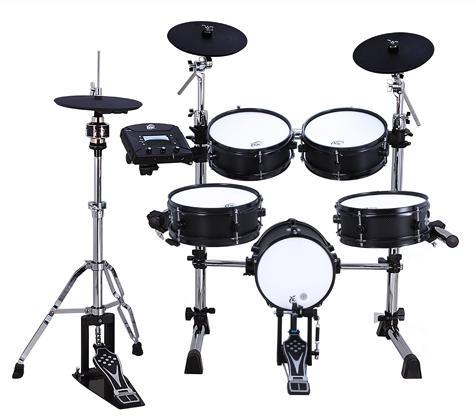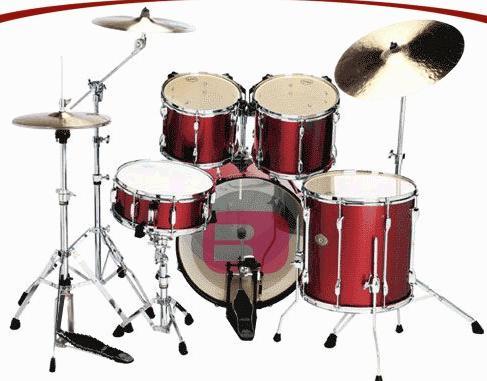The first image is the image on the left, the second image is the image on the right. Given the left and right images, does the statement "One image features a drum kit with the central large drum showing a black round side, and the other image features a drum kit with the central large drum showing a round white side." hold true? Answer yes or no. No. The first image is the image on the left, the second image is the image on the right. For the images shown, is this caption "The kick drum skin in the left image is black." true? Answer yes or no. No. 